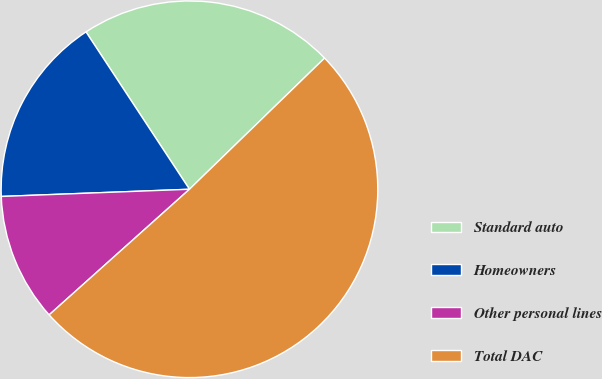Convert chart to OTSL. <chart><loc_0><loc_0><loc_500><loc_500><pie_chart><fcel>Standard auto<fcel>Homeowners<fcel>Other personal lines<fcel>Total DAC<nl><fcel>21.99%<fcel>16.35%<fcel>11.01%<fcel>50.64%<nl></chart> 